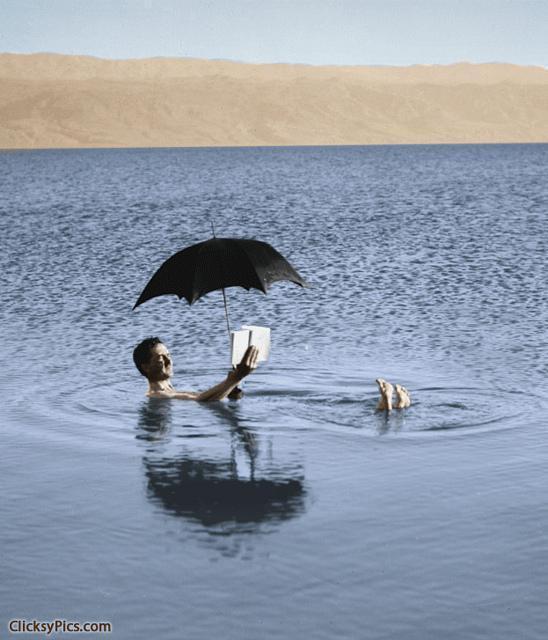Why is the man holding an umbrella?
Indicate the correct response by choosing from the four available options to answer the question.
Options: To swim, for cosplay, to dance, for shade. For shade. 